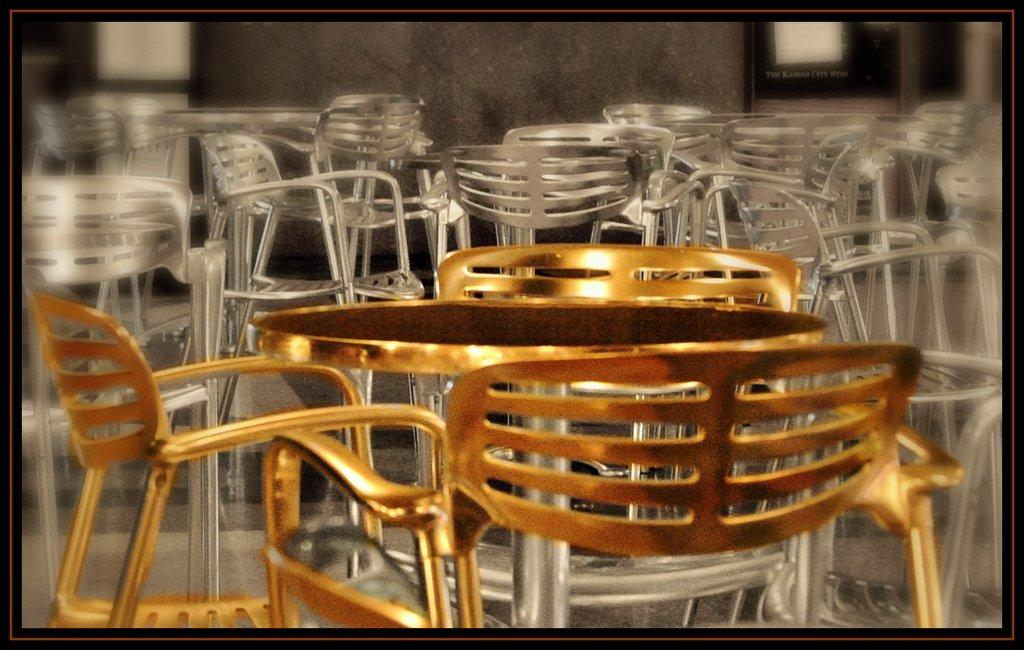How many chairs are present in the image? There are three chairs in the image. What is the color of the three chairs? The three chairs are golden in color. What other furniture is present in the image? There is a table in the image. What is the color of the table? The table is golden in color. How do the other chairs and tables in the image differ in color? The rest of the chairs and tables in the image are silver in color. What type of ink is used to write on the golden table in the image? There is no indication in the image that anything is being written on the table, and therefore no ink is present. 